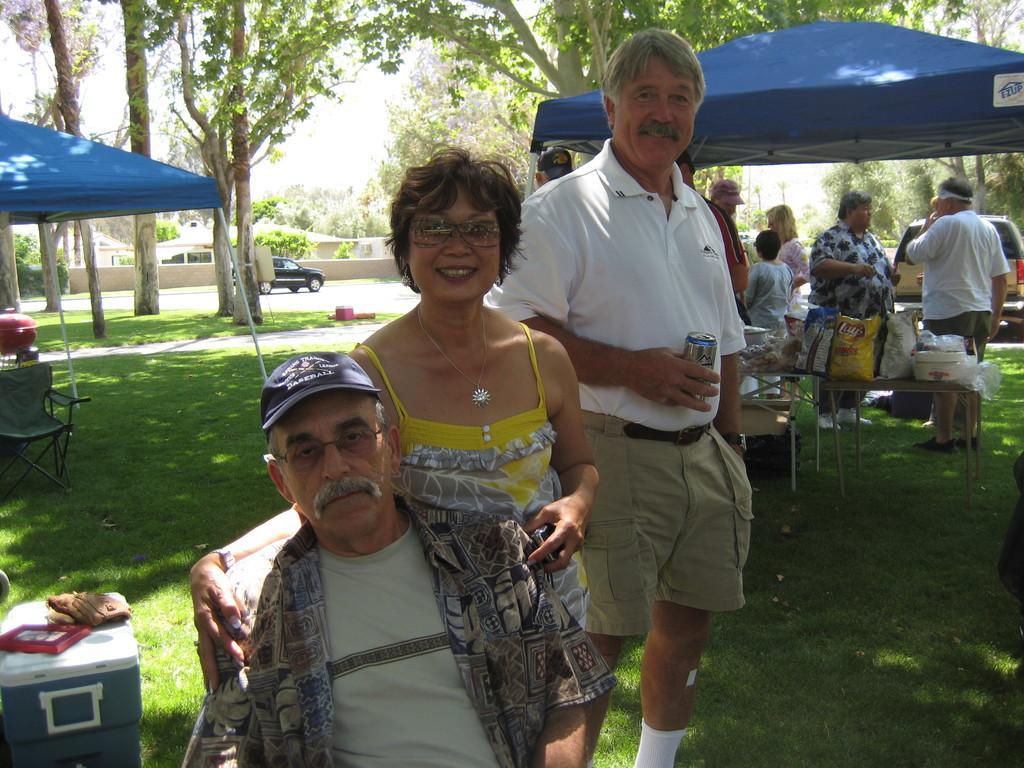In one or two sentences, can you explain what this image depicts? In the middle of the image there is a man with spectacles and cap on the head. Behind him there is a lady with spectacles is standing. Behind her there is a man standing and holding a can in the hand. There are many people standing and also there are tables with many items on it. Above them there is tent. On the left corner of the image there are boxes and some other things on the ground. And also there is tent. In the background there are many trees and also there are two cars. There are buildings and fencing walls. 